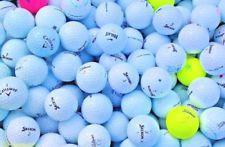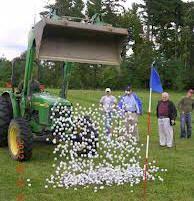The first image is the image on the left, the second image is the image on the right. For the images displayed, is the sentence "In at least one image there is a pile of white golf balls and at least one yellow golf ball." factually correct? Answer yes or no. Yes. The first image is the image on the left, the second image is the image on the right. Assess this claim about the two images: "Some of the balls are not white in one image and all the balls are white in the other image.". Correct or not? Answer yes or no. Yes. 